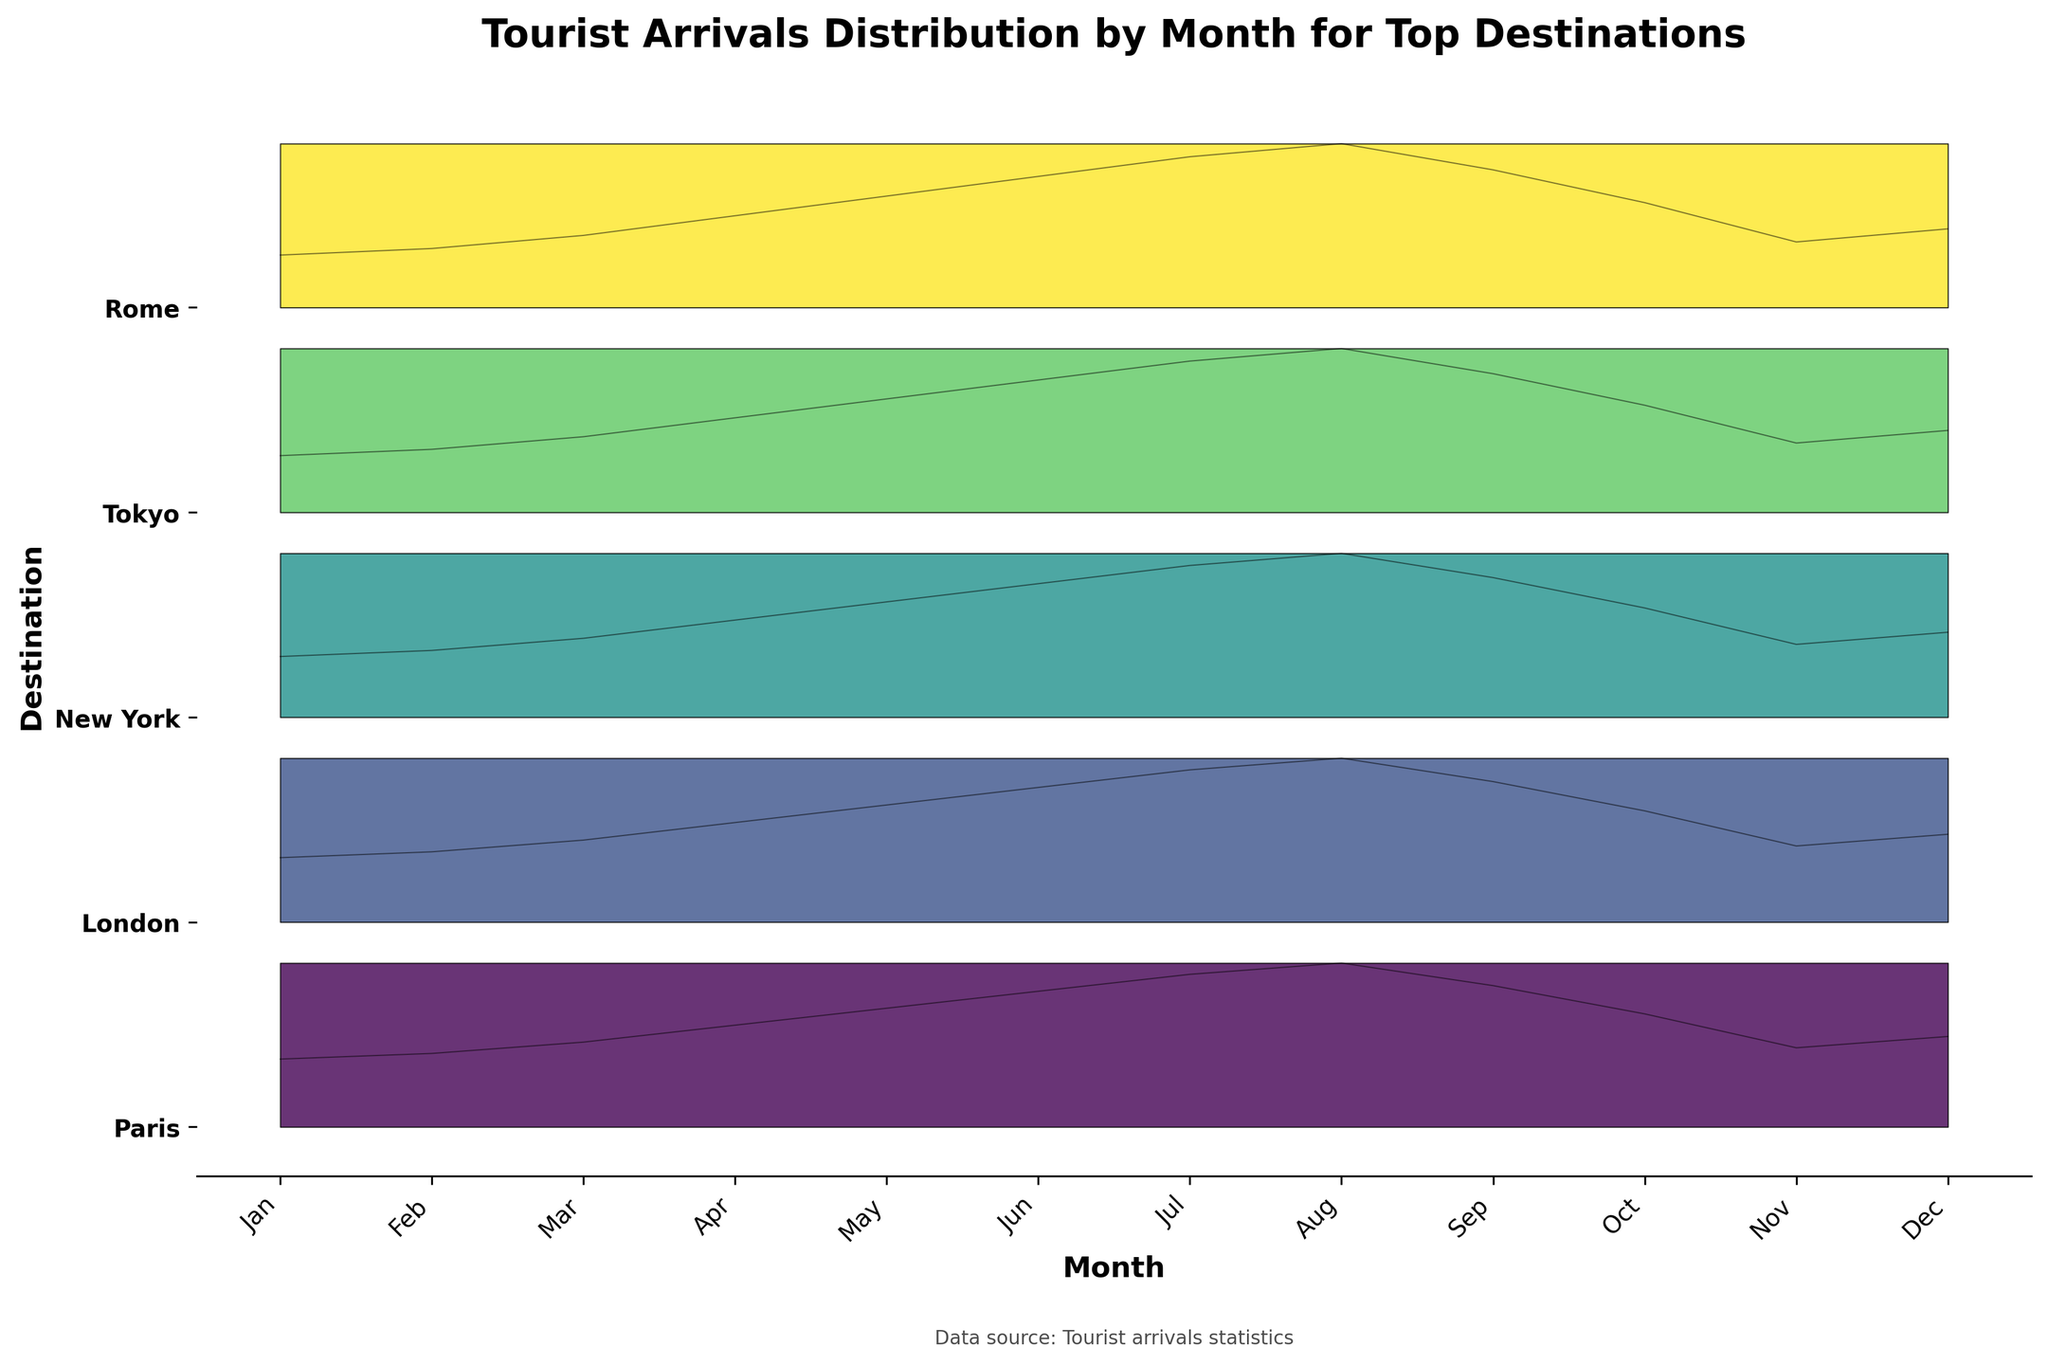Which destination has the highest tourist arrivals in July? To find this, look at the different curves for July and identify the one that reaches the highest point on the y-axis in terms of normalized arrivals.
Answer: Paris What is the trend of tourist arrivals in New York from January to December? Observe the New York curve and note the changes in height over the year: January starts lower, then peaks in the summer months (July and August), and then declines towards December.
Answer: Rising till August, then declining During which month does Paris see a noticeable drop in tourist arrivals after a peak? Look at the curve for Paris and identify the peak months; then see when the arrivals drop off significantly afterward.
Answer: September Which destination shows the most stable trend in tourist arrivals throughout the year? Examine the general shape and fluctuations in each destination’s curve; the one with the least variance between months would be the most stable.
Answer: Tokyo How do tourist arrivals compare in October for Paris and Rome? Compare the heights of the curves for Paris and Rome in October, normalized to their individual maximums.
Answer: Paris has higher arrivals Which month shows the highest peak in tourist arrivals for all destinations combined? Sum the peaks of all destination curves for each month and identify which month has the highest cumulative peak.
Answer: August Does London have higher tourist arrivals than New York in May? Compare the heights of London’s and New York’s curves in May to see which one reaches higher.
Answer: Yes What can you infer about the offseason for Tokyo based on the plot? Identify the months where Tokyo’s curve is at its lowest, indicating fewer tourist arrivals.
Answer: January and November During which month is there the least tourist activity for Rome? Find the minimum point on Rome's curve across all months.
Answer: January Which destination sees the highest increase in tourist arrivals between January and April? Compare the increases in normalized heights of the curves from January to April for all destinations and identify the greatest increase.
Answer: Paris 